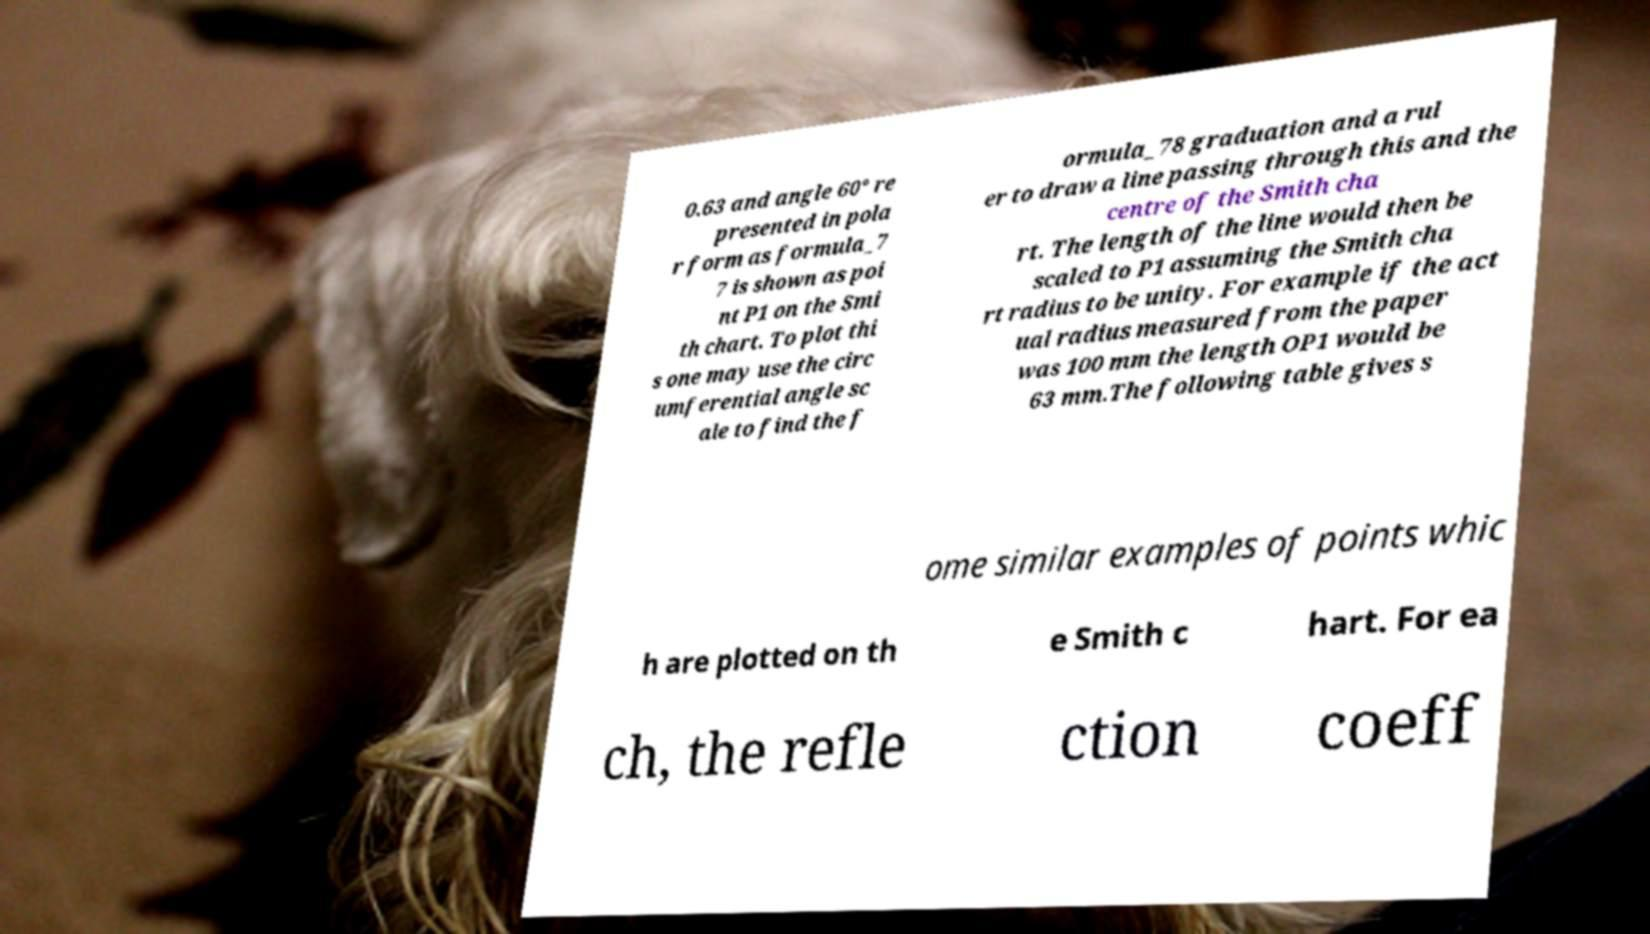For documentation purposes, I need the text within this image transcribed. Could you provide that? 0.63 and angle 60° re presented in pola r form as formula_7 7 is shown as poi nt P1 on the Smi th chart. To plot thi s one may use the circ umferential angle sc ale to find the f ormula_78 graduation and a rul er to draw a line passing through this and the centre of the Smith cha rt. The length of the line would then be scaled to P1 assuming the Smith cha rt radius to be unity. For example if the act ual radius measured from the paper was 100 mm the length OP1 would be 63 mm.The following table gives s ome similar examples of points whic h are plotted on th e Smith c hart. For ea ch, the refle ction coeff 